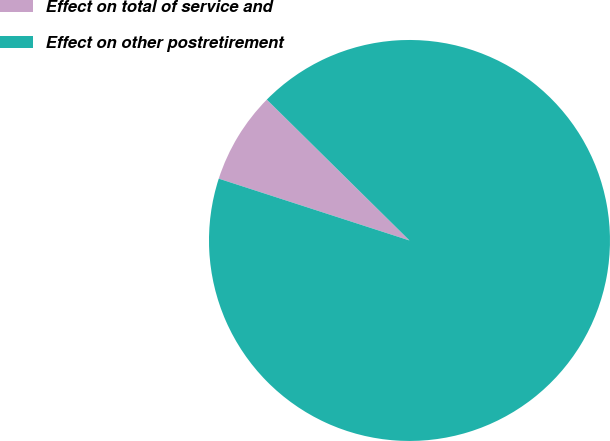<chart> <loc_0><loc_0><loc_500><loc_500><pie_chart><fcel>Effect on total of service and<fcel>Effect on other postretirement<nl><fcel>7.41%<fcel>92.59%<nl></chart> 